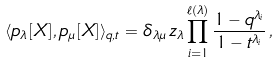Convert formula to latex. <formula><loc_0><loc_0><loc_500><loc_500>\langle p _ { \lambda } [ X ] , p _ { \mu } [ X ] \rangle _ { q , t } = \delta _ { \lambda \mu } \, z _ { \lambda } \prod _ { i = 1 } ^ { \ell ( \lambda ) } \frac { 1 - q ^ { \lambda _ { i } } } { 1 - t ^ { \lambda _ { i } } } \, ,</formula> 